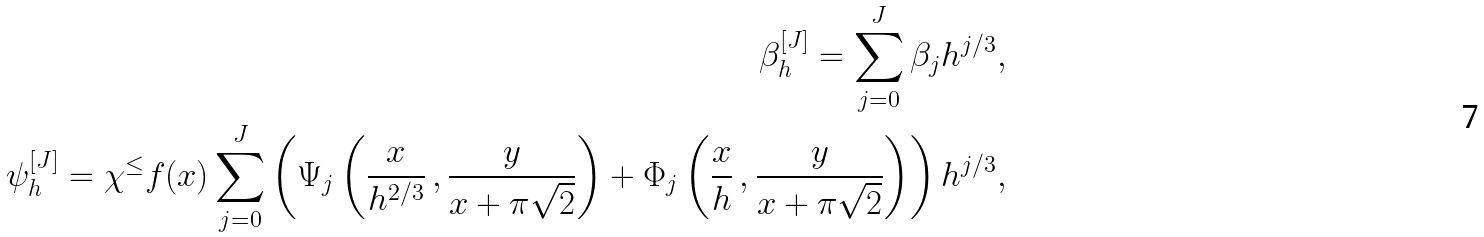<formula> <loc_0><loc_0><loc_500><loc_500>\beta ^ { [ J ] } _ { h } = \sum _ { j = 0 } ^ { J } \beta _ { j } h ^ { j / 3 } , \\ \psi _ { h } ^ { [ J ] } = \chi ^ { \leq } f ( x ) \sum _ { j = 0 } ^ { J } \left ( \Psi _ { j } \left ( \frac { x } { h ^ { 2 / 3 } } \, , \frac { y } { x + \pi \sqrt { 2 } } \right ) + \Phi _ { j } \left ( \frac { x } { h } \, , \frac { y } { x + \pi \sqrt { 2 } } \right ) \right ) h ^ { j / 3 } ,</formula> 